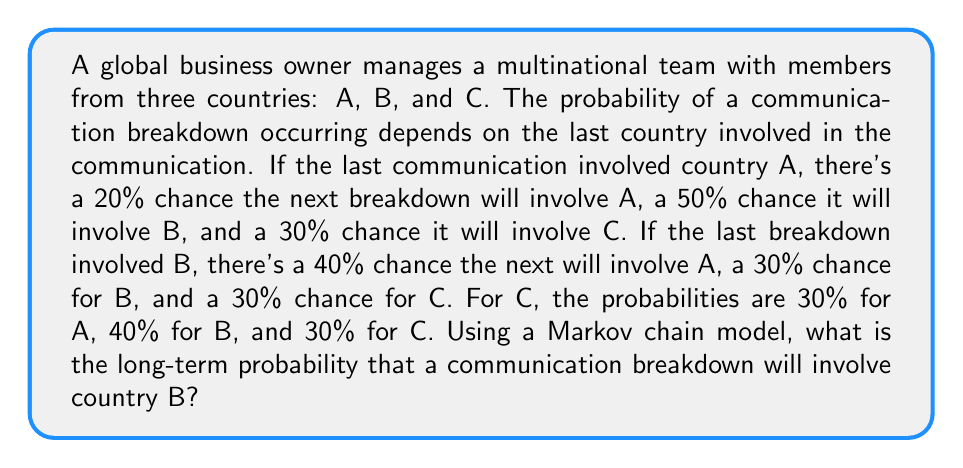Show me your answer to this math problem. To solve this problem, we'll use a Markov chain model and find its steady-state probabilities. Let's follow these steps:

1. Construct the transition matrix P:
   $$P = \begin{bmatrix}
   0.2 & 0.5 & 0.3 \\
   0.4 & 0.3 & 0.3 \\
   0.3 & 0.4 & 0.3
   \end{bmatrix}$$

2. Find the steady-state probabilities by solving the equation:
   $$\pi P = \pi$$
   where $\pi = [\pi_A, \pi_B, \pi_C]$ is the vector of steady-state probabilities.

3. This gives us the system of equations:
   $$\begin{cases}
   0.2\pi_A + 0.4\pi_B + 0.3\pi_C = \pi_A \\
   0.5\pi_A + 0.3\pi_B + 0.4\pi_C = \pi_B \\
   0.3\pi_A + 0.3\pi_B + 0.3\pi_C = \pi_C
   \end{cases}$$

4. We also know that $\pi_A + \pi_B + \pi_C = 1$

5. Simplify the equations:
   $$\begin{cases}
   0.8\pi_A - 0.4\pi_B - 0.3\pi_C = 0 \\
   -0.5\pi_A + 0.7\pi_B - 0.4\pi_C = 0 \\
   \pi_A + \pi_B + \pi_C = 1
   \end{cases}$$

6. Solve this system of equations:
   $$\pi_A = \frac{11}{30} \approx 0.3667$$
   $$\pi_B = \frac{13}{30} \approx 0.4333$$
   $$\pi_C = \frac{6}{30} = 0.2$$

7. The long-term probability of a communication breakdown involving country B is $\pi_B = \frac{13}{30}$.
Answer: $\frac{13}{30}$ or approximately 0.4333 